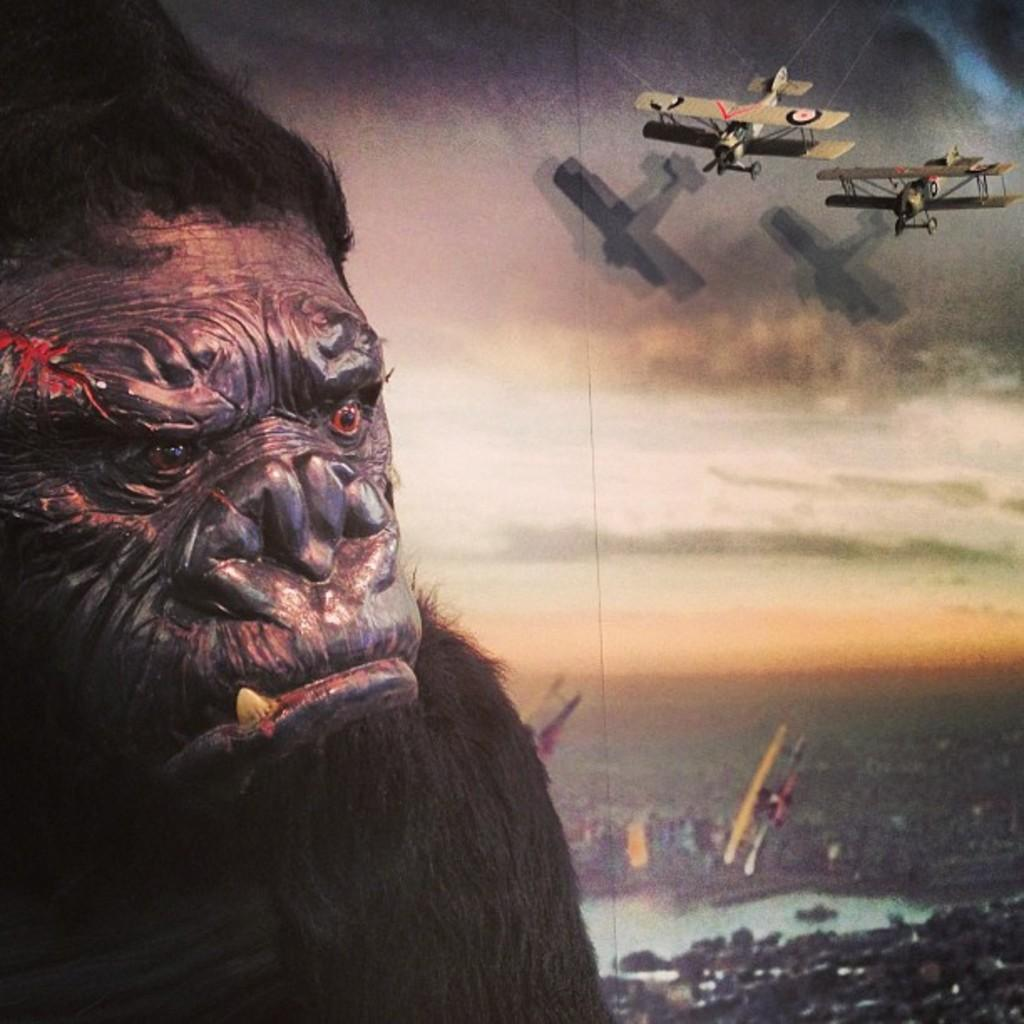What is the main subject of the image? The main subject of the image is planes. Can you describe the animal on the left side of the image? Unfortunately, the facts provided do not give any information about the animal, so we cannot describe it. What type of fuel is being used by the planes in the image? The facts provided do not mention any information about the fuel being used by the planes, so we cannot determine the type of fuel. 